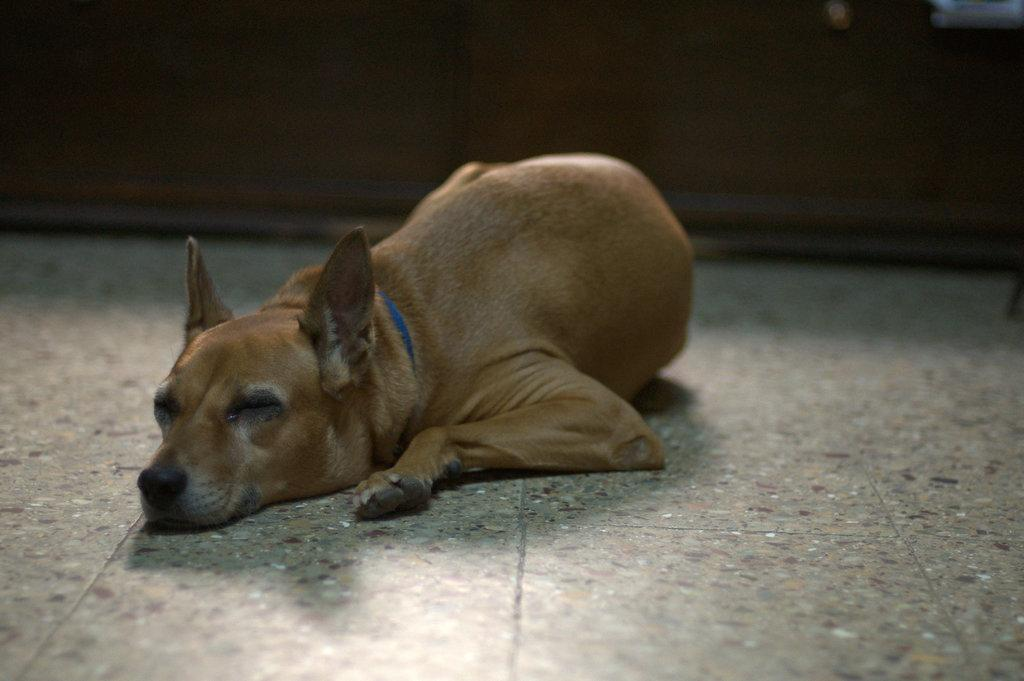What animal can be seen in the image? There is a dog in the image. What position is the dog in? The dog is lying on the floor. What can be seen behind the dog in the image? There appears to be a wall in the background of the image. What type of quiver is the dog holding in the image? There is no quiver present in the image; the dog is simply lying on the floor. 